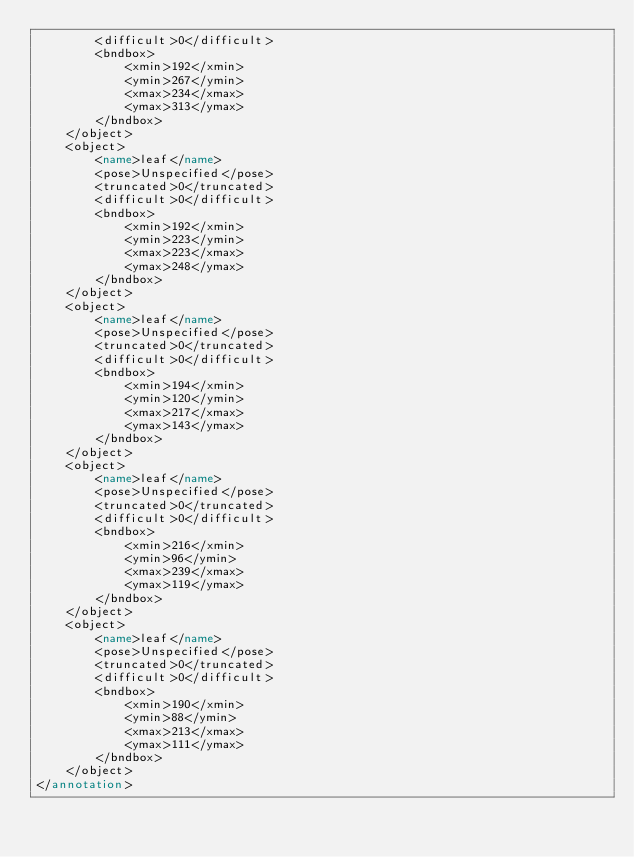<code> <loc_0><loc_0><loc_500><loc_500><_XML_>        <difficult>0</difficult>
        <bndbox>
            <xmin>192</xmin>
            <ymin>267</ymin>
            <xmax>234</xmax>
            <ymax>313</ymax>
        </bndbox>
    </object>
    <object>
        <name>leaf</name>
        <pose>Unspecified</pose>
        <truncated>0</truncated>
        <difficult>0</difficult>
        <bndbox>
            <xmin>192</xmin>
            <ymin>223</ymin>
            <xmax>223</xmax>
            <ymax>248</ymax>
        </bndbox>
    </object>
    <object>
        <name>leaf</name>
        <pose>Unspecified</pose>
        <truncated>0</truncated>
        <difficult>0</difficult>
        <bndbox>
            <xmin>194</xmin>
            <ymin>120</ymin>
            <xmax>217</xmax>
            <ymax>143</ymax>
        </bndbox>
    </object>
    <object>
        <name>leaf</name>
        <pose>Unspecified</pose>
        <truncated>0</truncated>
        <difficult>0</difficult>
        <bndbox>
            <xmin>216</xmin>
            <ymin>96</ymin>
            <xmax>239</xmax>
            <ymax>119</ymax>
        </bndbox>
    </object>
    <object>
        <name>leaf</name>
        <pose>Unspecified</pose>
        <truncated>0</truncated>
        <difficult>0</difficult>
        <bndbox>
            <xmin>190</xmin>
            <ymin>88</ymin>
            <xmax>213</xmax>
            <ymax>111</ymax>
        </bndbox>
    </object>
</annotation>
</code> 